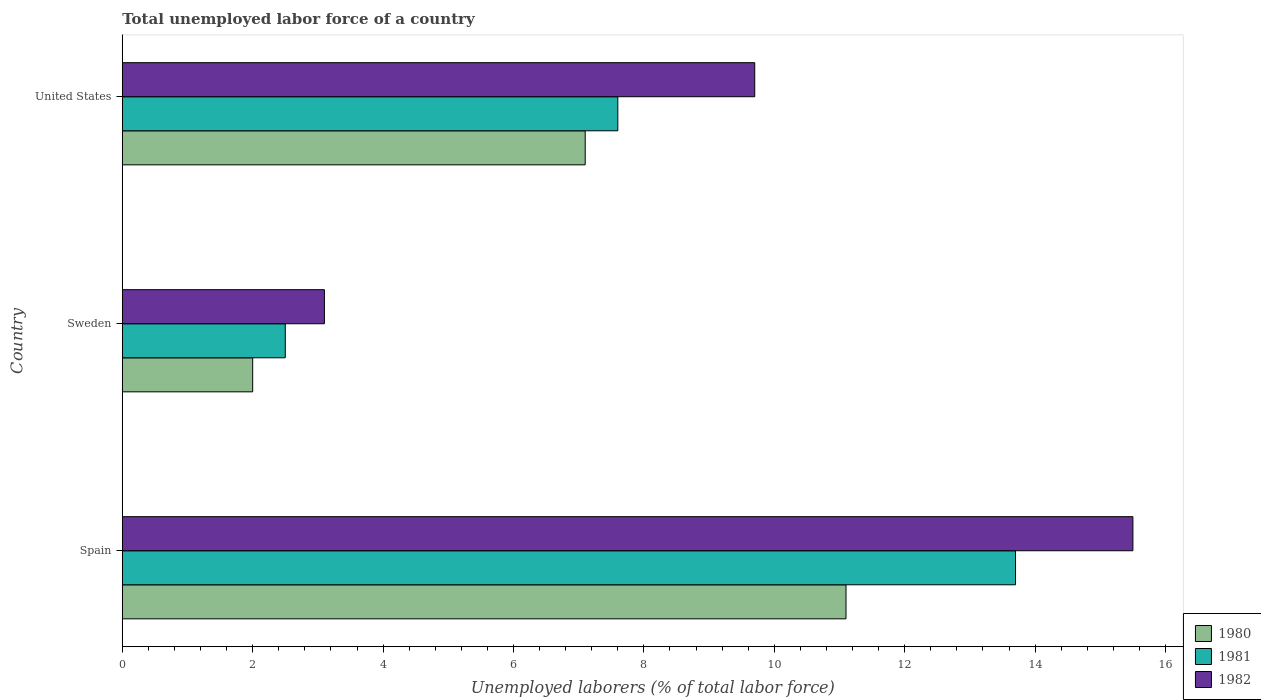How many different coloured bars are there?
Provide a short and direct response. 3. How many groups of bars are there?
Offer a very short reply. 3. Are the number of bars per tick equal to the number of legend labels?
Your answer should be compact. Yes. How many bars are there on the 2nd tick from the top?
Ensure brevity in your answer.  3. What is the total unemployed labor force in 1981 in United States?
Provide a short and direct response. 7.6. Across all countries, what is the maximum total unemployed labor force in 1980?
Ensure brevity in your answer.  11.1. Across all countries, what is the minimum total unemployed labor force in 1982?
Keep it short and to the point. 3.1. In which country was the total unemployed labor force in 1982 maximum?
Offer a terse response. Spain. What is the total total unemployed labor force in 1982 in the graph?
Your answer should be compact. 28.3. What is the difference between the total unemployed labor force in 1981 in Spain and that in Sweden?
Make the answer very short. 11.2. What is the difference between the total unemployed labor force in 1982 in United States and the total unemployed labor force in 1980 in Sweden?
Your answer should be very brief. 7.7. What is the average total unemployed labor force in 1980 per country?
Provide a succinct answer. 6.73. In how many countries, is the total unemployed labor force in 1980 greater than 3.6 %?
Give a very brief answer. 2. What is the ratio of the total unemployed labor force in 1982 in Spain to that in Sweden?
Provide a succinct answer. 5. Is the total unemployed labor force in 1982 in Sweden less than that in United States?
Offer a terse response. Yes. What is the difference between the highest and the second highest total unemployed labor force in 1980?
Your response must be concise. 4. What is the difference between the highest and the lowest total unemployed labor force in 1981?
Ensure brevity in your answer.  11.2. Is the sum of the total unemployed labor force in 1982 in Sweden and United States greater than the maximum total unemployed labor force in 1980 across all countries?
Provide a short and direct response. Yes. What does the 2nd bar from the top in Sweden represents?
Provide a short and direct response. 1981. What does the 2nd bar from the bottom in Spain represents?
Offer a terse response. 1981. Is it the case that in every country, the sum of the total unemployed labor force in 1980 and total unemployed labor force in 1981 is greater than the total unemployed labor force in 1982?
Provide a succinct answer. Yes. How many bars are there?
Give a very brief answer. 9. Are all the bars in the graph horizontal?
Offer a terse response. Yes. How many countries are there in the graph?
Provide a short and direct response. 3. Are the values on the major ticks of X-axis written in scientific E-notation?
Make the answer very short. No. Does the graph contain grids?
Ensure brevity in your answer.  No. Where does the legend appear in the graph?
Provide a succinct answer. Bottom right. How many legend labels are there?
Offer a very short reply. 3. What is the title of the graph?
Provide a short and direct response. Total unemployed labor force of a country. Does "1968" appear as one of the legend labels in the graph?
Your response must be concise. No. What is the label or title of the X-axis?
Ensure brevity in your answer.  Unemployed laborers (% of total labor force). What is the Unemployed laborers (% of total labor force) of 1980 in Spain?
Your answer should be very brief. 11.1. What is the Unemployed laborers (% of total labor force) in 1981 in Spain?
Provide a short and direct response. 13.7. What is the Unemployed laborers (% of total labor force) of 1982 in Spain?
Give a very brief answer. 15.5. What is the Unemployed laborers (% of total labor force) in 1980 in Sweden?
Offer a terse response. 2. What is the Unemployed laborers (% of total labor force) of 1982 in Sweden?
Make the answer very short. 3.1. What is the Unemployed laborers (% of total labor force) in 1980 in United States?
Your response must be concise. 7.1. What is the Unemployed laborers (% of total labor force) in 1981 in United States?
Make the answer very short. 7.6. What is the Unemployed laborers (% of total labor force) of 1982 in United States?
Your response must be concise. 9.7. Across all countries, what is the maximum Unemployed laborers (% of total labor force) in 1980?
Your response must be concise. 11.1. Across all countries, what is the maximum Unemployed laborers (% of total labor force) in 1981?
Your response must be concise. 13.7. Across all countries, what is the minimum Unemployed laborers (% of total labor force) of 1980?
Your answer should be compact. 2. Across all countries, what is the minimum Unemployed laborers (% of total labor force) in 1981?
Ensure brevity in your answer.  2.5. Across all countries, what is the minimum Unemployed laborers (% of total labor force) of 1982?
Offer a very short reply. 3.1. What is the total Unemployed laborers (% of total labor force) of 1980 in the graph?
Offer a very short reply. 20.2. What is the total Unemployed laborers (% of total labor force) in 1981 in the graph?
Ensure brevity in your answer.  23.8. What is the total Unemployed laborers (% of total labor force) of 1982 in the graph?
Keep it short and to the point. 28.3. What is the difference between the Unemployed laborers (% of total labor force) in 1980 in Spain and that in Sweden?
Provide a succinct answer. 9.1. What is the difference between the Unemployed laborers (% of total labor force) in 1982 in Spain and that in Sweden?
Make the answer very short. 12.4. What is the difference between the Unemployed laborers (% of total labor force) of 1981 in Spain and that in United States?
Your answer should be very brief. 6.1. What is the difference between the Unemployed laborers (% of total labor force) in 1982 in Spain and that in United States?
Your response must be concise. 5.8. What is the difference between the Unemployed laborers (% of total labor force) in 1980 in Sweden and that in United States?
Your response must be concise. -5.1. What is the difference between the Unemployed laborers (% of total labor force) in 1982 in Sweden and that in United States?
Provide a short and direct response. -6.6. What is the difference between the Unemployed laborers (% of total labor force) of 1981 in Spain and the Unemployed laborers (% of total labor force) of 1982 in Sweden?
Offer a terse response. 10.6. What is the difference between the Unemployed laborers (% of total labor force) of 1980 in Sweden and the Unemployed laborers (% of total labor force) of 1981 in United States?
Your answer should be compact. -5.6. What is the difference between the Unemployed laborers (% of total labor force) in 1980 in Sweden and the Unemployed laborers (% of total labor force) in 1982 in United States?
Provide a succinct answer. -7.7. What is the average Unemployed laborers (% of total labor force) in 1980 per country?
Keep it short and to the point. 6.73. What is the average Unemployed laborers (% of total labor force) of 1981 per country?
Your answer should be compact. 7.93. What is the average Unemployed laborers (% of total labor force) in 1982 per country?
Ensure brevity in your answer.  9.43. What is the difference between the Unemployed laborers (% of total labor force) of 1980 and Unemployed laborers (% of total labor force) of 1981 in Spain?
Your response must be concise. -2.6. What is the difference between the Unemployed laborers (% of total labor force) in 1980 and Unemployed laborers (% of total labor force) in 1981 in Sweden?
Offer a terse response. -0.5. What is the difference between the Unemployed laborers (% of total labor force) of 1980 and Unemployed laborers (% of total labor force) of 1982 in Sweden?
Keep it short and to the point. -1.1. What is the difference between the Unemployed laborers (% of total labor force) in 1980 and Unemployed laborers (% of total labor force) in 1981 in United States?
Keep it short and to the point. -0.5. What is the difference between the Unemployed laborers (% of total labor force) in 1980 and Unemployed laborers (% of total labor force) in 1982 in United States?
Offer a very short reply. -2.6. What is the ratio of the Unemployed laborers (% of total labor force) in 1980 in Spain to that in Sweden?
Ensure brevity in your answer.  5.55. What is the ratio of the Unemployed laborers (% of total labor force) in 1981 in Spain to that in Sweden?
Offer a very short reply. 5.48. What is the ratio of the Unemployed laborers (% of total labor force) of 1980 in Spain to that in United States?
Offer a terse response. 1.56. What is the ratio of the Unemployed laborers (% of total labor force) in 1981 in Spain to that in United States?
Give a very brief answer. 1.8. What is the ratio of the Unemployed laborers (% of total labor force) in 1982 in Spain to that in United States?
Provide a short and direct response. 1.6. What is the ratio of the Unemployed laborers (% of total labor force) of 1980 in Sweden to that in United States?
Give a very brief answer. 0.28. What is the ratio of the Unemployed laborers (% of total labor force) in 1981 in Sweden to that in United States?
Your response must be concise. 0.33. What is the ratio of the Unemployed laborers (% of total labor force) in 1982 in Sweden to that in United States?
Ensure brevity in your answer.  0.32. What is the difference between the highest and the second highest Unemployed laborers (% of total labor force) of 1980?
Give a very brief answer. 4. What is the difference between the highest and the lowest Unemployed laborers (% of total labor force) of 1982?
Your answer should be very brief. 12.4. 